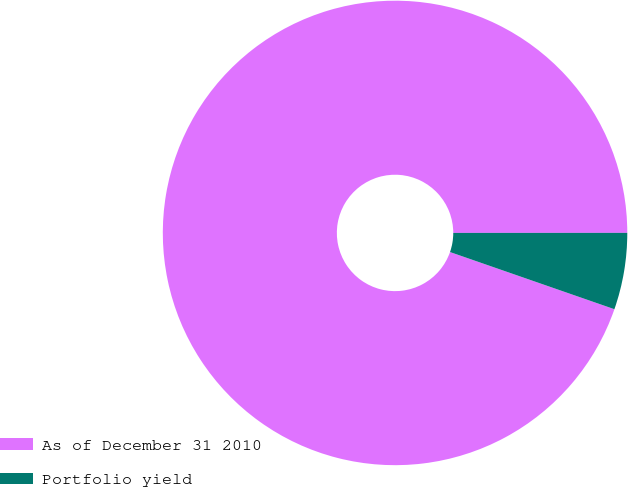Convert chart. <chart><loc_0><loc_0><loc_500><loc_500><pie_chart><fcel>As of December 31 2010<fcel>Portfolio yield<nl><fcel>94.67%<fcel>5.33%<nl></chart> 